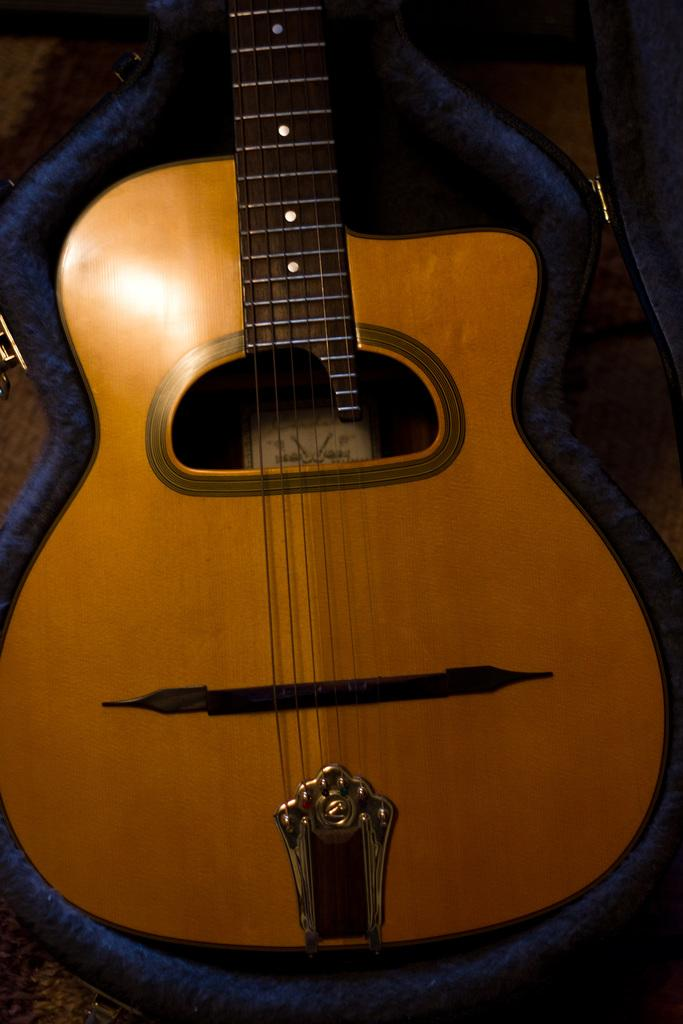What musical instrument is present in the image? There is a guitar in the image. Is there anything related to the guitar's protection or storage in the image? Yes, there is a guitar cover in the image. What type of paper can be seen in the throat of the guitar in the image? There is no paper visible in the throat of the guitar in the image. 